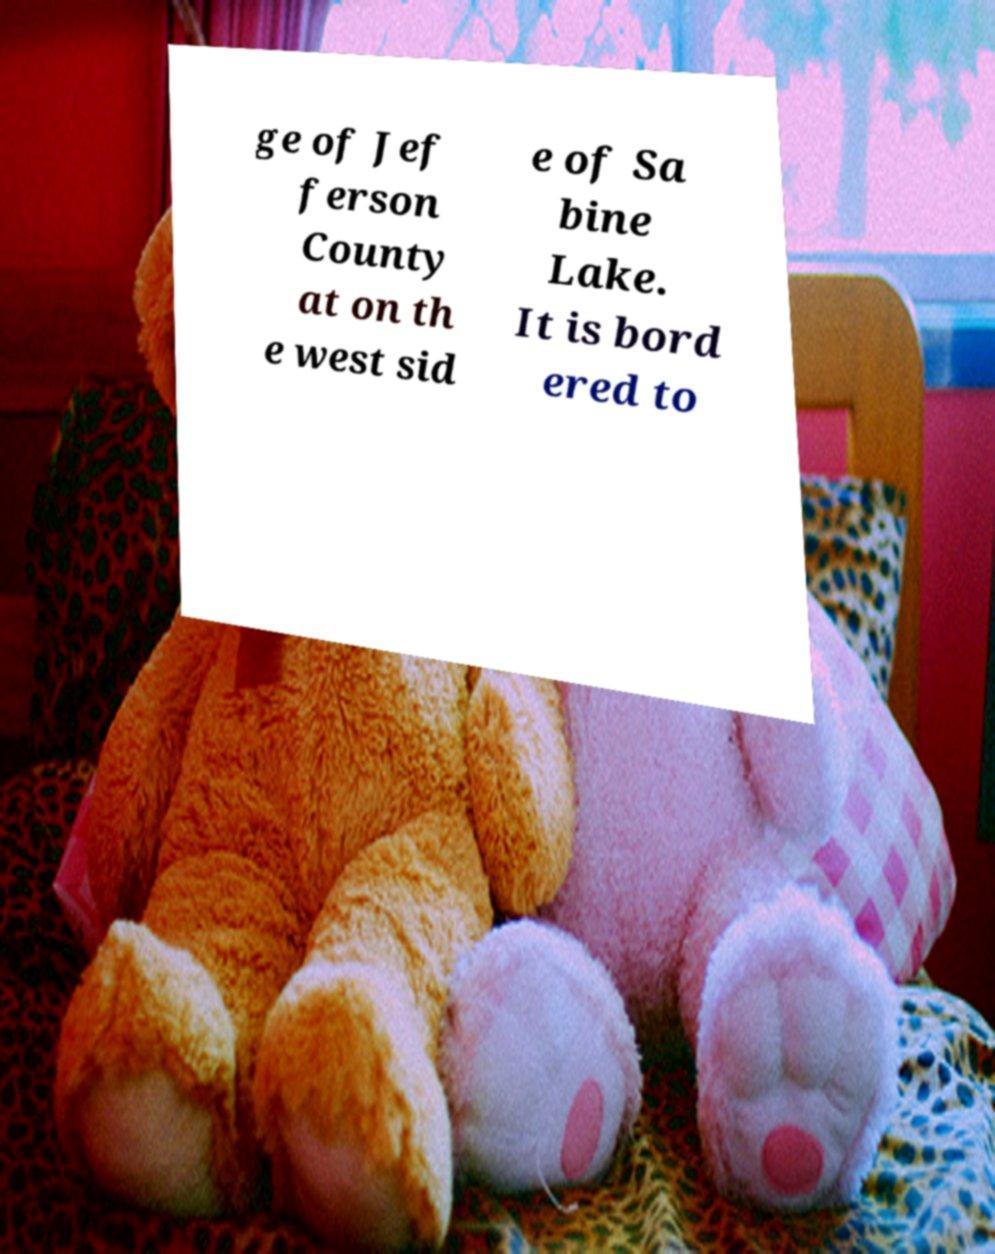Please read and relay the text visible in this image. What does it say? ge of Jef ferson County at on th e west sid e of Sa bine Lake. It is bord ered to 